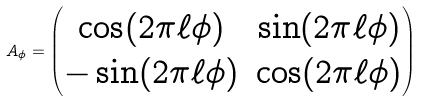Convert formula to latex. <formula><loc_0><loc_0><loc_500><loc_500>A _ { \phi } = \begin{pmatrix} \cos ( 2 \pi \ell \phi ) & \sin ( 2 \pi \ell \phi ) \\ - \sin ( 2 \pi \ell \phi ) & \cos ( 2 \pi \ell \phi ) \end{pmatrix}</formula> 